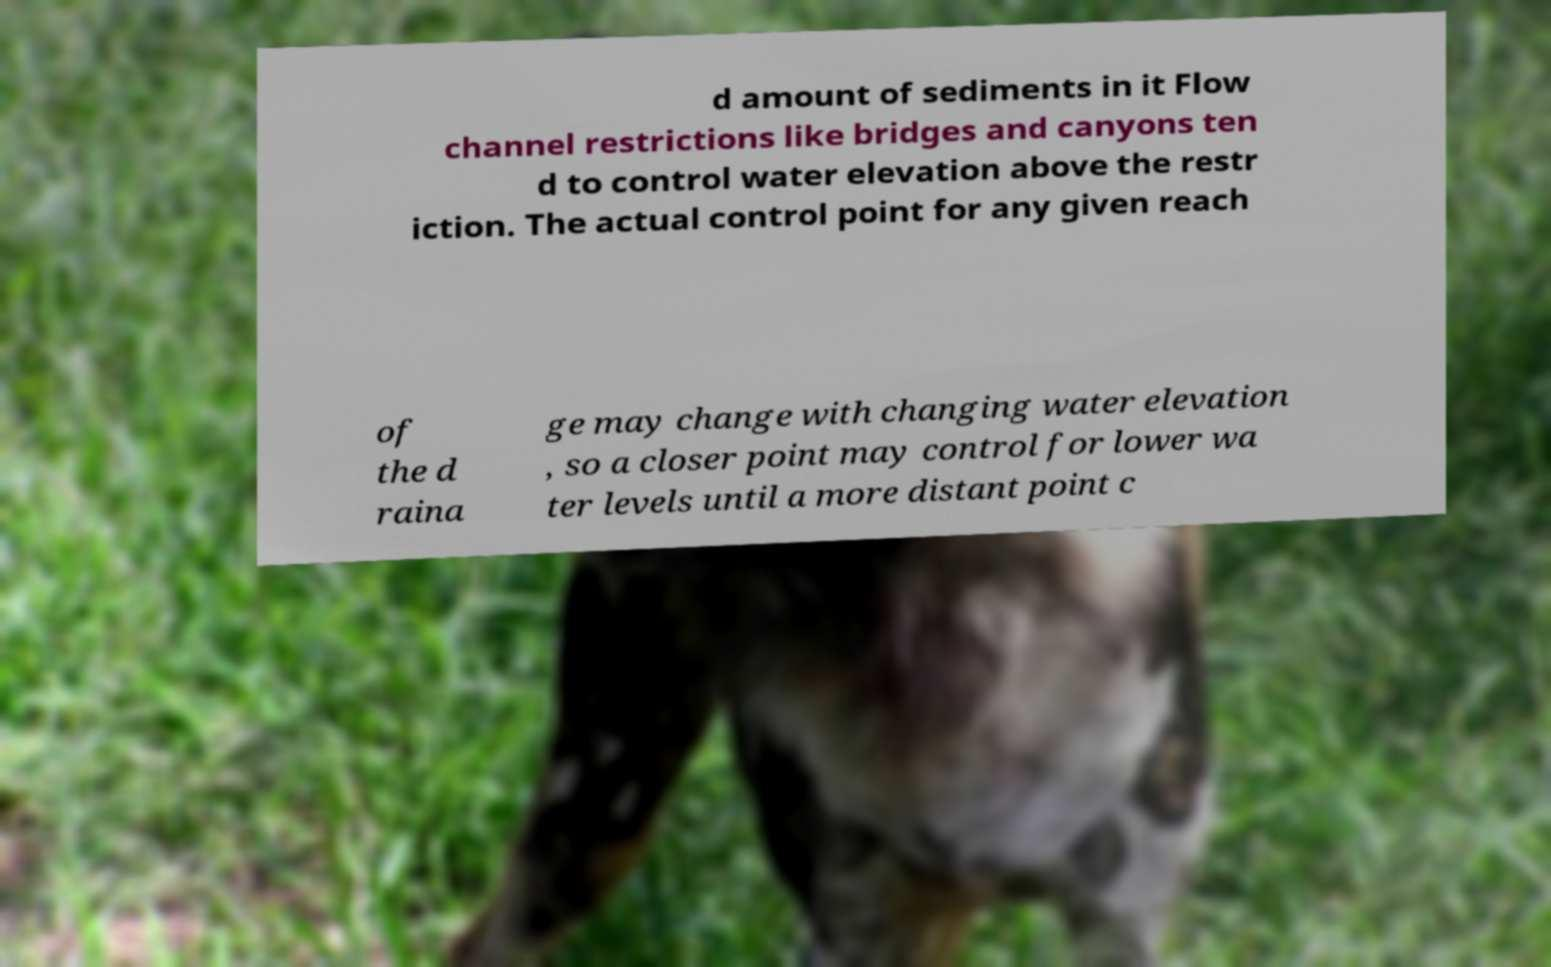Please identify and transcribe the text found in this image. d amount of sediments in it Flow channel restrictions like bridges and canyons ten d to control water elevation above the restr iction. The actual control point for any given reach of the d raina ge may change with changing water elevation , so a closer point may control for lower wa ter levels until a more distant point c 